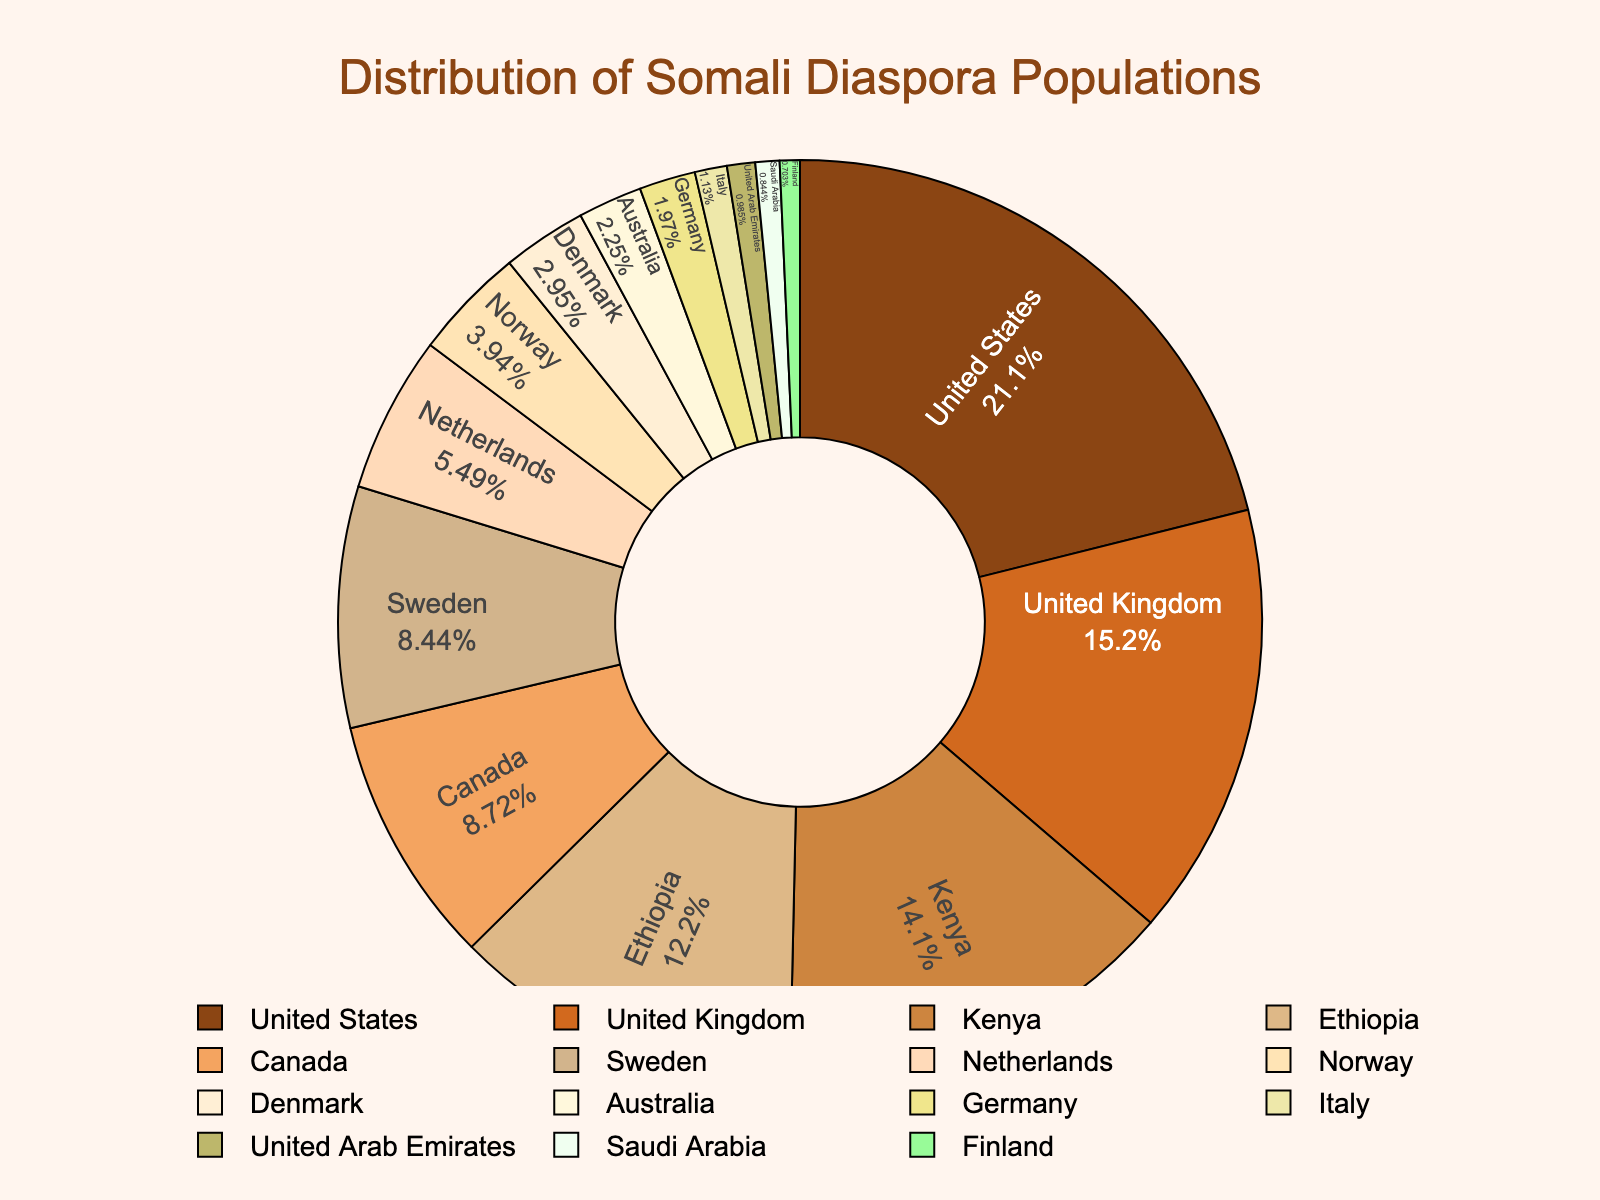Which country hosts the largest population of the Somali diaspora? The country with the largest segment on the pie chart represents the host country with the largest population of the Somali diaspora. This clearly is the United States.
Answer: United States Which two countries have the most similar population sizes of the Somali diaspora? The two countries with the most similar-sized segments in the pie chart are Denmark and Australia.
Answer: Denmark and Australia How many percentage points smaller is the Somali diaspora population in Canada compared to the United Kingdom? First, identify the sizes of the segments for Canada and the United Kingdom. The proportion for the United Kingdom is approximately 15.2% and for Canada, it is roughly 8.7%. Subtract the smaller percentage from the larger one (15.2% - 8.7% = 6.5%).
Answer: 6.5% What is the combined percentage of the Somali diaspora living in the United States, United Kingdom, and Kenya? Add the percentage values represented by the segments of these three countries. United States (~21.1%), United Kingdom (~15.2%), and Kenya (~14.1%) combined make (21.1% + 15.2% + 14.1% = 50.4%).
Answer: 50.4% How does the Somali diaspora population in Germany compare to that in Italy? Locate the segments for Germany and Italy in the pie chart. The segment for Germany is larger than that for Italy.
Answer: Greater Which host country has the smallest Somali diaspora population represented in the pie chart, and what percentage does it constitute? The smallest segment in the pie chart represents the United Arab Emirates, constituting around 0.7% of the total population.
Answer: United Arab Emirates, 0.7% What is the difference in the diaspora population between Sweden and the Netherlands? Subtract the population of the Netherlands segment from the Sweden segment: (60000 - 39000 = 21000).
Answer: 21000 Considering the visual attributes, which segment is represented with a pale hue? The segments in pale hues include Finland and Saudi Arabia, which both appear very light compared to the others.
Answer: Finland and Saudi Arabia Is the population of the Somali diaspora in Norway more or less than double that in Denmark? Norway's segment shows 28000, and Denmark's shows 21000. Doubling Denmark's population is 42000, which is larger than Norway's segment. Hence, it is less than double.
Answer: Less Which three countries, excluding the top three, contribute approximately equal shares to the Somali diaspora population? By visually inspecting the pie chart, Canada, Sweden, and the Netherlands seem to have approximately equal-sized segments, contributing similar shares to the total population.
Answer: Canada, Sweden, Netherlands 